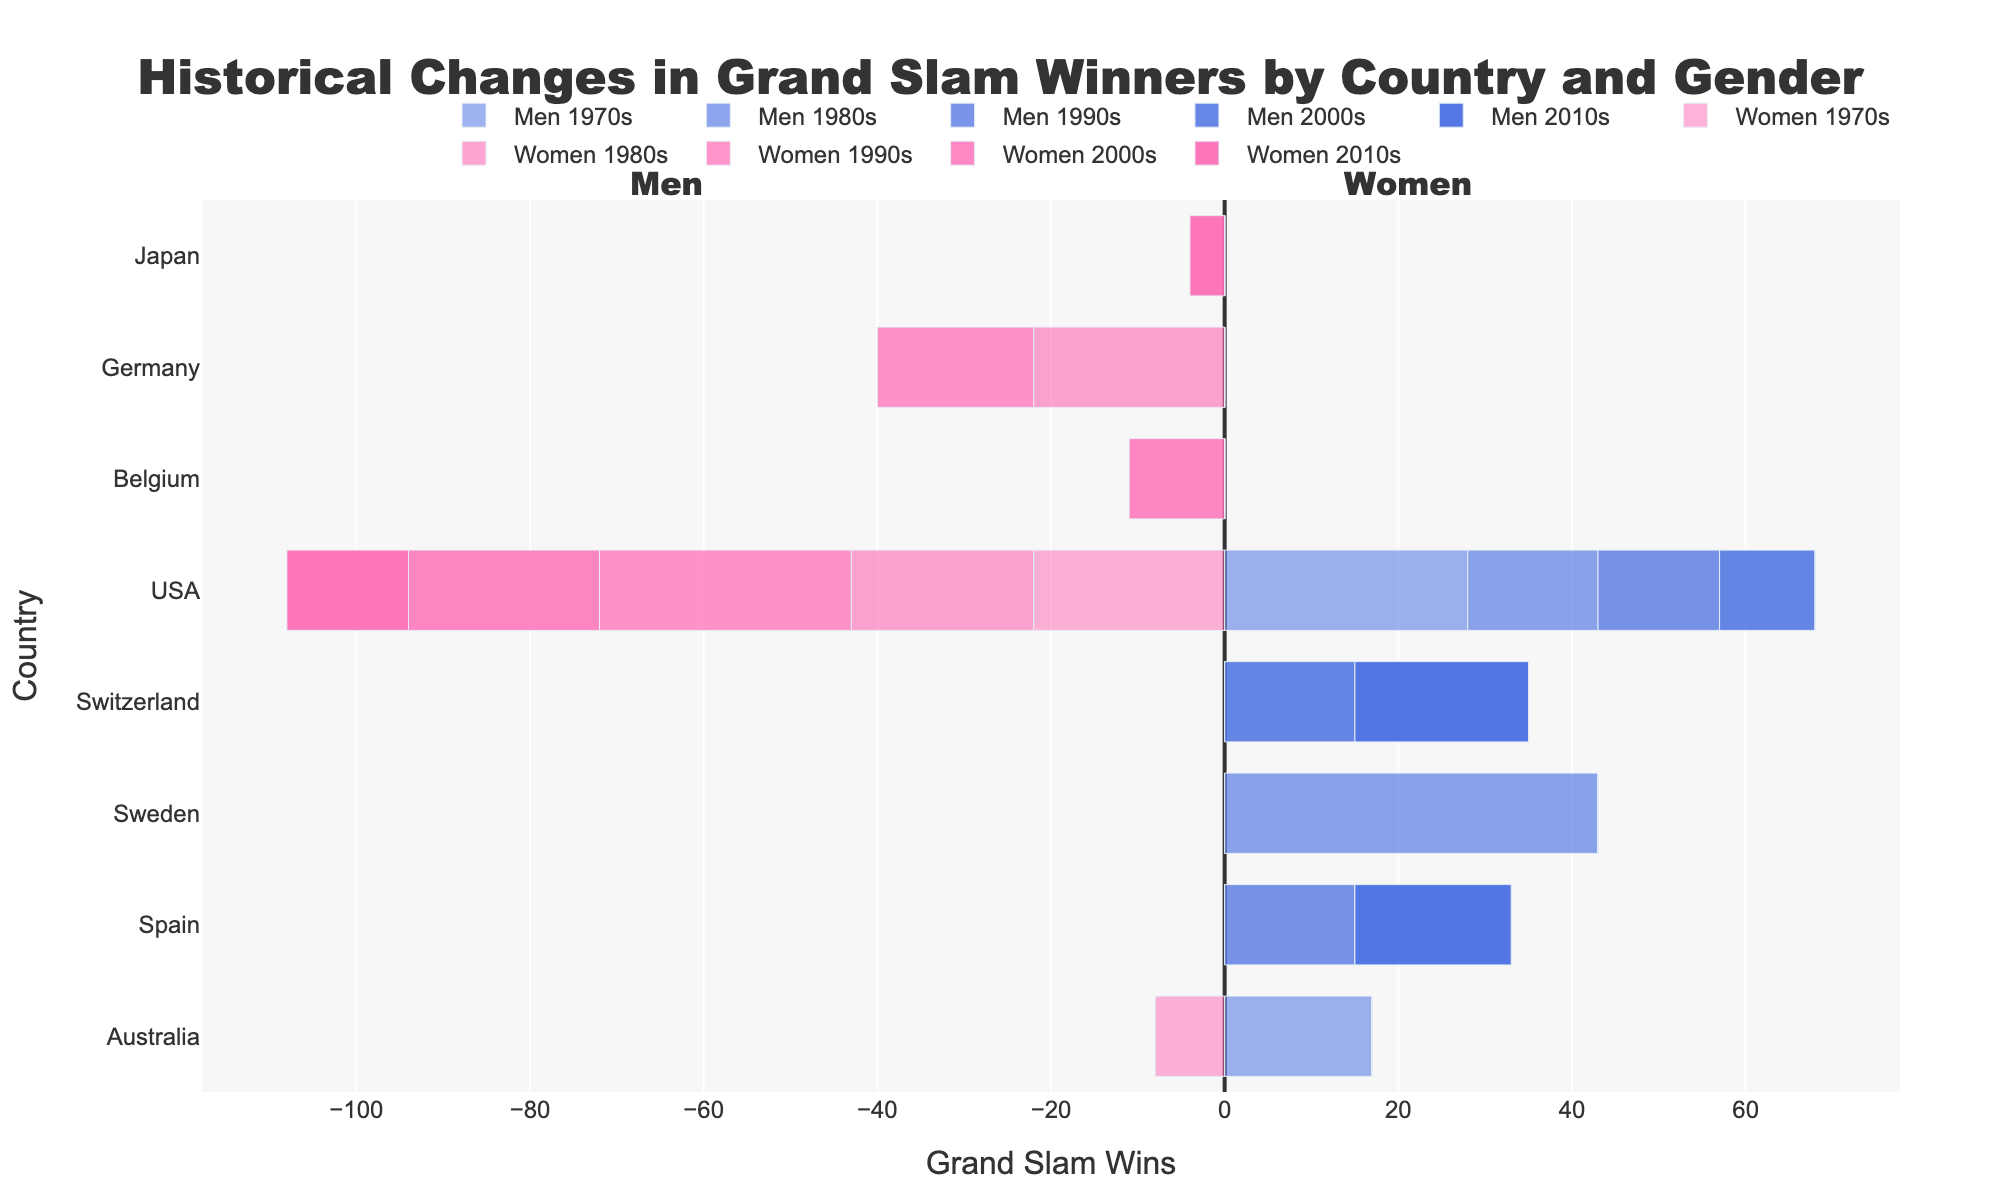Which country had the highest number of men's Grand Slam wins in the 1980s? By examining the length of the bars for each country in the 1980s section for men, we notice that Sweden has the longest bar representing 43 wins.
Answer: Sweden How did the number of Grand Slam wins by USA women change from the 1980s to the 1990s? The USA women's bar in the 1980s is 21, and in the 1990s, it is 29. By calculating the difference, 29 - 21 = 8, we see an increase of 8 wins.
Answer: Increased by 8 Which decade saw the highest combined Grand Slam wins (men and women) for the USA? We sum the men's and women's Grand Slam wins for each decade: 1970s (28+22=50), 1980s (15+21=36), 1990s (14+29=43), 2000s (11+22=33), 2010s (0+14=14). The 1970s with 50 wins have the highest combined total.
Answer: 1970s Compare the number of Grand Slam wins by Australian men in the 1970s to their wins by Australian women in the same decade. By comparing the length of the bars for Australia in the 1970s, we see 17 wins for men and 8 wins for women. So, Australian men had 9 more wins (17-8=9) than Australian women.
Answer: Men had 9 more wins In which decade did Japan's women achieve their Grand Slam wins, and how many did they win? By examining the bars, we see that Japan's women only appear in the 2010s section with a bar indicating 4 Grand Slam wins.
Answer: 2010s, 4 wins Which country's men had more Grand Slam wins in the 2010s, Spain or Switzerland? By comparing the lengths of the bars for Spain and Switzerland in the 2010s for men, Spain has 18 wins, and Switzerland has 20 wins, meaning Switzerland had 2 more wins than Spain (20 - 18 = 2).
Answer: Switzerland What is the total number of Grand Slam wins by German women across all decades? Summing up the values for German women: 1980s (22) and 1990s (18), we get 22 + 18 = 40.
Answer: 40 Which country's men are represented in all the decades shown in the chart and how does their performance trend? USA men's wins are shown in each decade from the 1970s. Their performance trends are: 28 (1970s), 15 (1980s), 14 (1990s), 11 (2000s), 0 (2010s), indicating a general downward trend.
Answer: USA, downward trend Who dominated the men's Grand Slam wins in the 1970s, and how many wins did the second highest country have? USA men dominated the 1970s with 28 wins, and Australian men had the second highest with 17 wins.
Answer: USA, 17 wins for Australia Did USA women have more wins in the 2000s or the 1970s, and by how many? Comparing the bars for USA women in the 2000s and 1970s, the numbers are 22 each. Thus, they had equal wins in both decades.
Answer: Equal, 0 